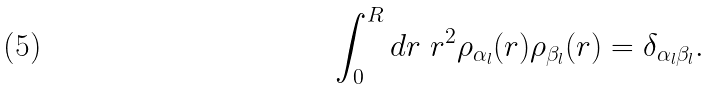<formula> <loc_0><loc_0><loc_500><loc_500>\int _ { 0 } ^ { R } d r \ r ^ { 2 } \rho _ { \alpha _ { l } } ( r ) \rho _ { \beta _ { l } } ( r ) = \delta _ { \alpha _ { l } \beta _ { l } } .</formula> 